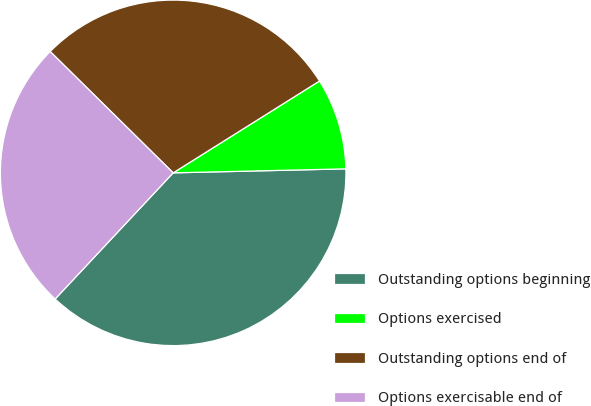Convert chart to OTSL. <chart><loc_0><loc_0><loc_500><loc_500><pie_chart><fcel>Outstanding options beginning<fcel>Options exercised<fcel>Outstanding options end of<fcel>Options exercisable end of<nl><fcel>37.34%<fcel>8.55%<fcel>28.69%<fcel>25.42%<nl></chart> 